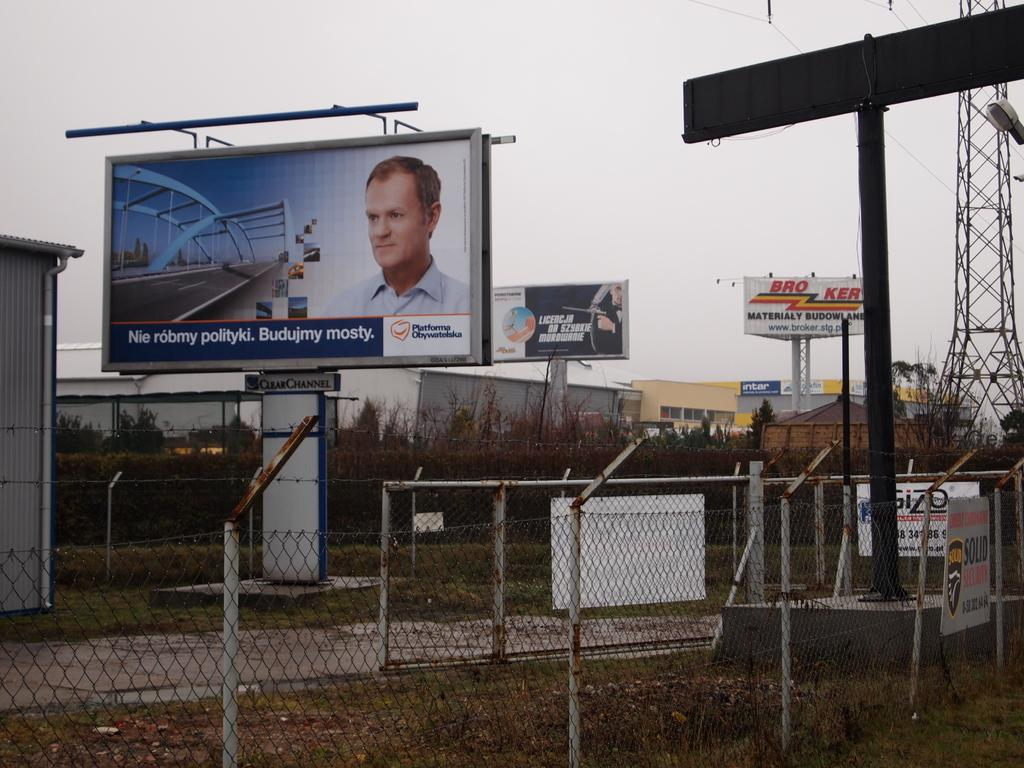<image>
Write a terse but informative summary of the picture. Multiple billboards are shown outside including one that says Broker. 